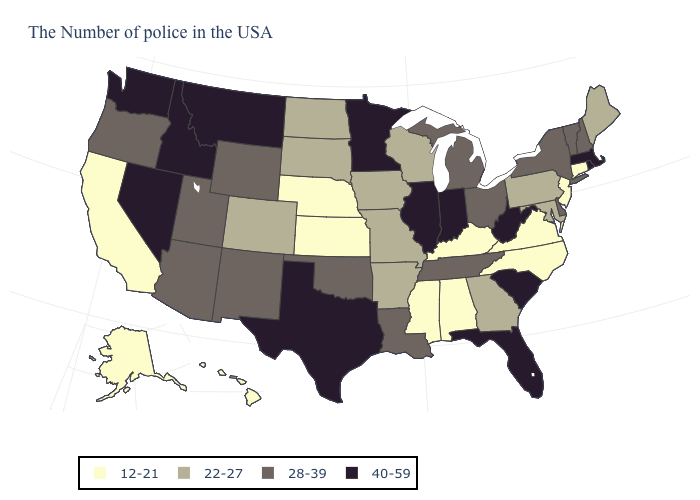Does the map have missing data?
Concise answer only. No. How many symbols are there in the legend?
Concise answer only. 4. What is the value of Delaware?
Short answer required. 28-39. Among the states that border Kentucky , does Indiana have the highest value?
Keep it brief. Yes. Does Vermont have a lower value than Idaho?
Quick response, please. Yes. Is the legend a continuous bar?
Keep it brief. No. Name the states that have a value in the range 28-39?
Concise answer only. New Hampshire, Vermont, New York, Delaware, Ohio, Michigan, Tennessee, Louisiana, Oklahoma, Wyoming, New Mexico, Utah, Arizona, Oregon. Name the states that have a value in the range 28-39?
Keep it brief. New Hampshire, Vermont, New York, Delaware, Ohio, Michigan, Tennessee, Louisiana, Oklahoma, Wyoming, New Mexico, Utah, Arizona, Oregon. Name the states that have a value in the range 40-59?
Write a very short answer. Massachusetts, Rhode Island, South Carolina, West Virginia, Florida, Indiana, Illinois, Minnesota, Texas, Montana, Idaho, Nevada, Washington. Name the states that have a value in the range 40-59?
Write a very short answer. Massachusetts, Rhode Island, South Carolina, West Virginia, Florida, Indiana, Illinois, Minnesota, Texas, Montana, Idaho, Nevada, Washington. Which states have the highest value in the USA?
Write a very short answer. Massachusetts, Rhode Island, South Carolina, West Virginia, Florida, Indiana, Illinois, Minnesota, Texas, Montana, Idaho, Nevada, Washington. Name the states that have a value in the range 28-39?
Short answer required. New Hampshire, Vermont, New York, Delaware, Ohio, Michigan, Tennessee, Louisiana, Oklahoma, Wyoming, New Mexico, Utah, Arizona, Oregon. What is the value of Hawaii?
Concise answer only. 12-21. What is the value of Washington?
Concise answer only. 40-59. Name the states that have a value in the range 12-21?
Answer briefly. Connecticut, New Jersey, Virginia, North Carolina, Kentucky, Alabama, Mississippi, Kansas, Nebraska, California, Alaska, Hawaii. 